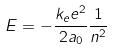Convert formula to latex. <formula><loc_0><loc_0><loc_500><loc_500>E = - \frac { k _ { e } e ^ { 2 } } { 2 a _ { 0 } } \frac { 1 } { n ^ { 2 } }</formula> 